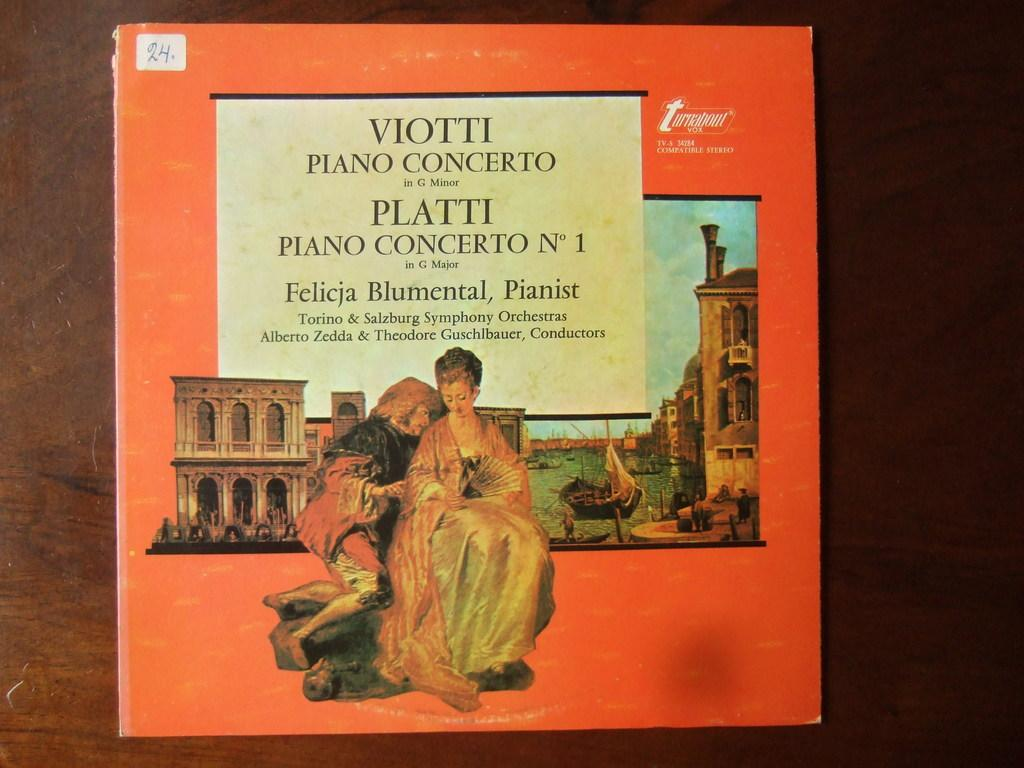<image>
Write a terse but informative summary of the picture. a book that says turnabout in the top right corner 